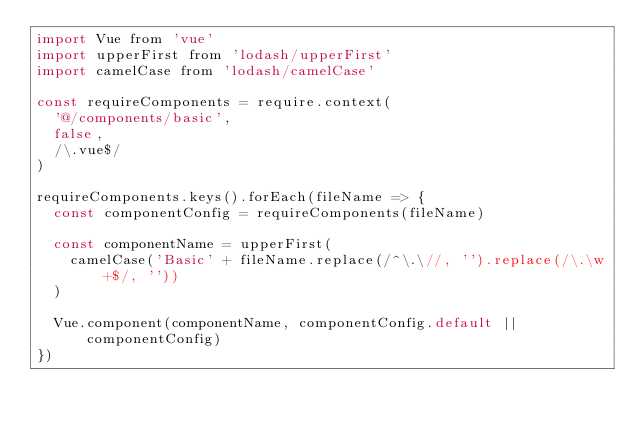<code> <loc_0><loc_0><loc_500><loc_500><_JavaScript_>import Vue from 'vue'
import upperFirst from 'lodash/upperFirst'
import camelCase from 'lodash/camelCase'

const requireComponents = require.context(
  '@/components/basic',
  false,
  /\.vue$/
)

requireComponents.keys().forEach(fileName => {
  const componentConfig = requireComponents(fileName)

  const componentName = upperFirst(
    camelCase('Basic' + fileName.replace(/^\.\//, '').replace(/\.\w+$/, ''))
  )

  Vue.component(componentName, componentConfig.default || componentConfig)
})
</code> 